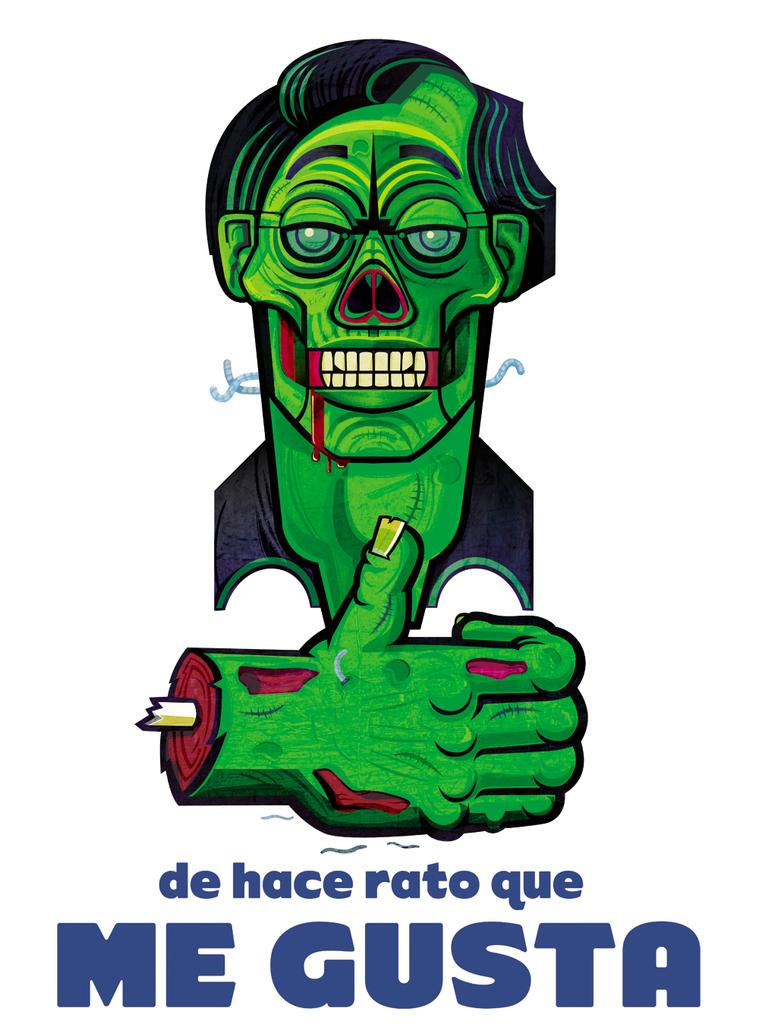<image>
Offer a succinct explanation of the picture presented. A picture of a green monster with the words de hace rato que me gusta. 